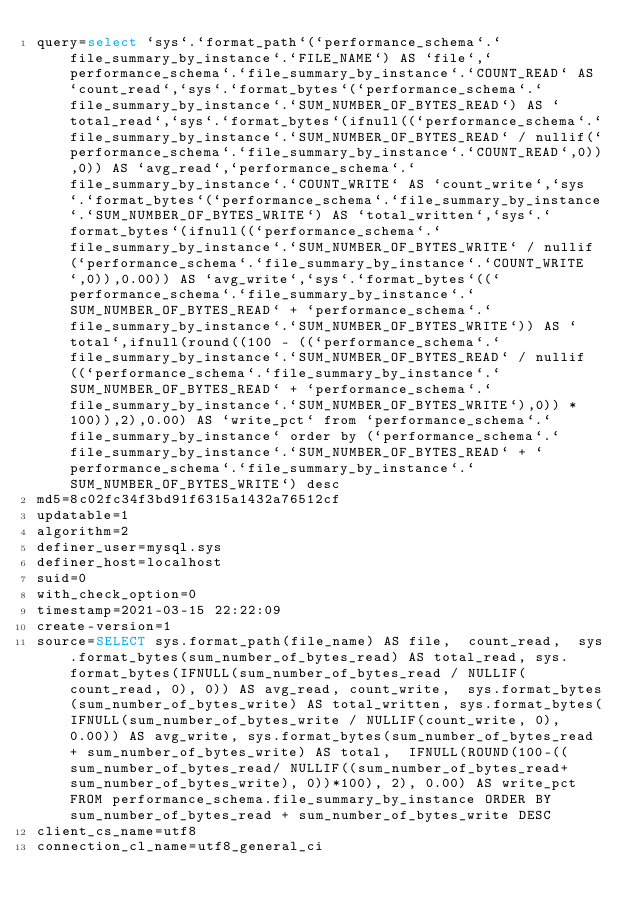<code> <loc_0><loc_0><loc_500><loc_500><_VisualBasic_>query=select `sys`.`format_path`(`performance_schema`.`file_summary_by_instance`.`FILE_NAME`) AS `file`,`performance_schema`.`file_summary_by_instance`.`COUNT_READ` AS `count_read`,`sys`.`format_bytes`(`performance_schema`.`file_summary_by_instance`.`SUM_NUMBER_OF_BYTES_READ`) AS `total_read`,`sys`.`format_bytes`(ifnull((`performance_schema`.`file_summary_by_instance`.`SUM_NUMBER_OF_BYTES_READ` / nullif(`performance_schema`.`file_summary_by_instance`.`COUNT_READ`,0)),0)) AS `avg_read`,`performance_schema`.`file_summary_by_instance`.`COUNT_WRITE` AS `count_write`,`sys`.`format_bytes`(`performance_schema`.`file_summary_by_instance`.`SUM_NUMBER_OF_BYTES_WRITE`) AS `total_written`,`sys`.`format_bytes`(ifnull((`performance_schema`.`file_summary_by_instance`.`SUM_NUMBER_OF_BYTES_WRITE` / nullif(`performance_schema`.`file_summary_by_instance`.`COUNT_WRITE`,0)),0.00)) AS `avg_write`,`sys`.`format_bytes`((`performance_schema`.`file_summary_by_instance`.`SUM_NUMBER_OF_BYTES_READ` + `performance_schema`.`file_summary_by_instance`.`SUM_NUMBER_OF_BYTES_WRITE`)) AS `total`,ifnull(round((100 - ((`performance_schema`.`file_summary_by_instance`.`SUM_NUMBER_OF_BYTES_READ` / nullif((`performance_schema`.`file_summary_by_instance`.`SUM_NUMBER_OF_BYTES_READ` + `performance_schema`.`file_summary_by_instance`.`SUM_NUMBER_OF_BYTES_WRITE`),0)) * 100)),2),0.00) AS `write_pct` from `performance_schema`.`file_summary_by_instance` order by (`performance_schema`.`file_summary_by_instance`.`SUM_NUMBER_OF_BYTES_READ` + `performance_schema`.`file_summary_by_instance`.`SUM_NUMBER_OF_BYTES_WRITE`) desc
md5=8c02fc34f3bd91f6315a1432a76512cf
updatable=1
algorithm=2
definer_user=mysql.sys
definer_host=localhost
suid=0
with_check_option=0
timestamp=2021-03-15 22:22:09
create-version=1
source=SELECT sys.format_path(file_name) AS file,  count_read,  sys.format_bytes(sum_number_of_bytes_read) AS total_read, sys.format_bytes(IFNULL(sum_number_of_bytes_read / NULLIF(count_read, 0), 0)) AS avg_read, count_write,  sys.format_bytes(sum_number_of_bytes_write) AS total_written, sys.format_bytes(IFNULL(sum_number_of_bytes_write / NULLIF(count_write, 0), 0.00)) AS avg_write, sys.format_bytes(sum_number_of_bytes_read + sum_number_of_bytes_write) AS total,  IFNULL(ROUND(100-((sum_number_of_bytes_read/ NULLIF((sum_number_of_bytes_read+sum_number_of_bytes_write), 0))*100), 2), 0.00) AS write_pct  FROM performance_schema.file_summary_by_instance ORDER BY sum_number_of_bytes_read + sum_number_of_bytes_write DESC
client_cs_name=utf8
connection_cl_name=utf8_general_ci</code> 